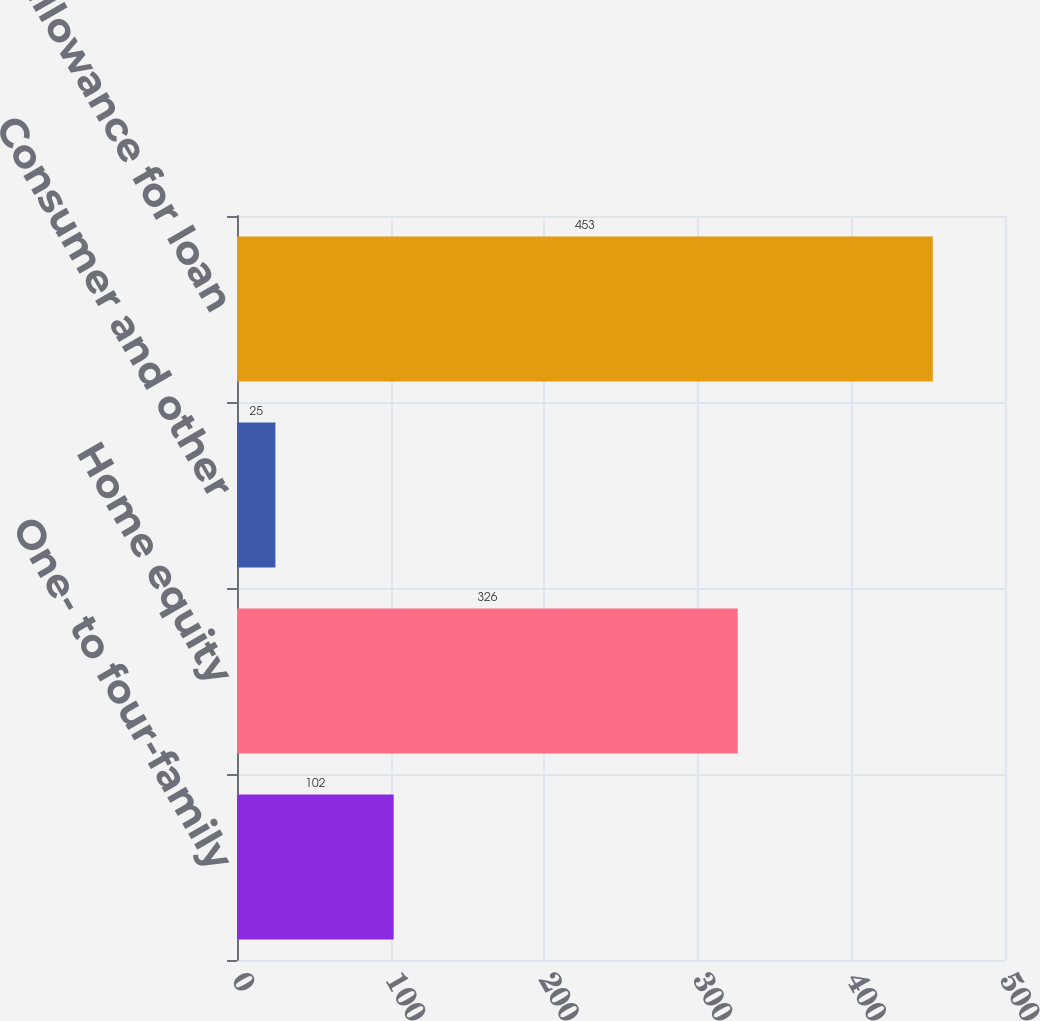<chart> <loc_0><loc_0><loc_500><loc_500><bar_chart><fcel>One- to four-family<fcel>Home equity<fcel>Consumer and other<fcel>Total allowance for loan<nl><fcel>102<fcel>326<fcel>25<fcel>453<nl></chart> 